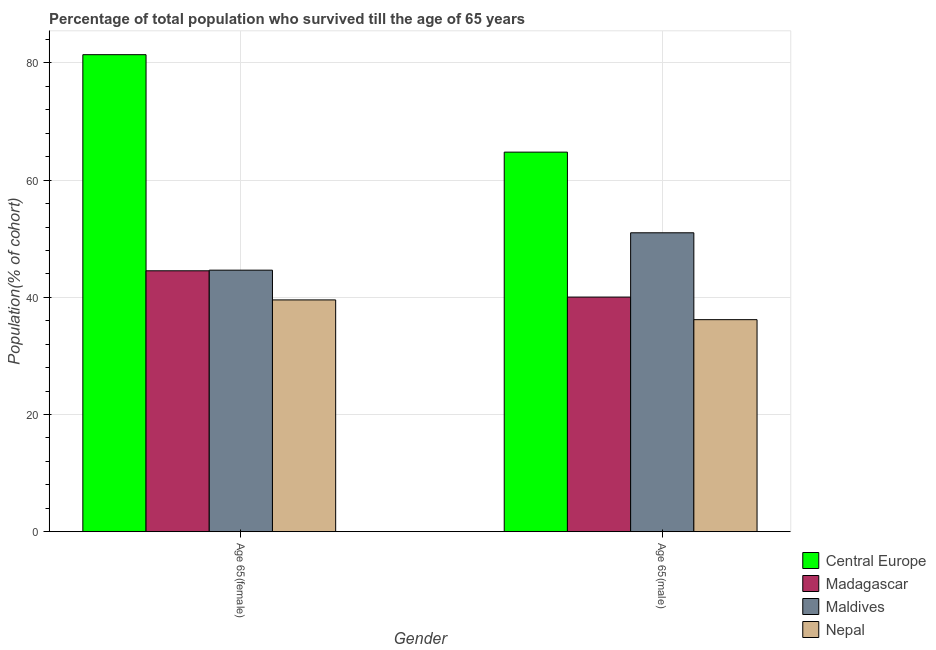How many bars are there on the 1st tick from the left?
Give a very brief answer. 4. What is the label of the 2nd group of bars from the left?
Keep it short and to the point. Age 65(male). What is the percentage of male population who survived till age of 65 in Madagascar?
Provide a succinct answer. 40.04. Across all countries, what is the maximum percentage of female population who survived till age of 65?
Provide a succinct answer. 81.41. Across all countries, what is the minimum percentage of female population who survived till age of 65?
Provide a succinct answer. 39.56. In which country was the percentage of female population who survived till age of 65 maximum?
Offer a terse response. Central Europe. In which country was the percentage of male population who survived till age of 65 minimum?
Offer a very short reply. Nepal. What is the total percentage of male population who survived till age of 65 in the graph?
Provide a succinct answer. 192.02. What is the difference between the percentage of female population who survived till age of 65 in Central Europe and that in Maldives?
Keep it short and to the point. 36.78. What is the difference between the percentage of female population who survived till age of 65 in Maldives and the percentage of male population who survived till age of 65 in Madagascar?
Provide a succinct answer. 4.59. What is the average percentage of female population who survived till age of 65 per country?
Your answer should be very brief. 52.53. What is the difference between the percentage of male population who survived till age of 65 and percentage of female population who survived till age of 65 in Madagascar?
Offer a terse response. -4.48. What is the ratio of the percentage of female population who survived till age of 65 in Nepal to that in Maldives?
Provide a succinct answer. 0.89. What does the 2nd bar from the left in Age 65(female) represents?
Keep it short and to the point. Madagascar. What does the 2nd bar from the right in Age 65(male) represents?
Offer a very short reply. Maldives. Are all the bars in the graph horizontal?
Your answer should be very brief. No. What is the difference between two consecutive major ticks on the Y-axis?
Your answer should be compact. 20. Does the graph contain any zero values?
Offer a terse response. No. Where does the legend appear in the graph?
Offer a very short reply. Bottom right. How many legend labels are there?
Offer a terse response. 4. What is the title of the graph?
Offer a very short reply. Percentage of total population who survived till the age of 65 years. What is the label or title of the Y-axis?
Offer a terse response. Population(% of cohort). What is the Population(% of cohort) of Central Europe in Age 65(female)?
Make the answer very short. 81.41. What is the Population(% of cohort) of Madagascar in Age 65(female)?
Provide a short and direct response. 44.53. What is the Population(% of cohort) in Maldives in Age 65(female)?
Provide a succinct answer. 44.63. What is the Population(% of cohort) in Nepal in Age 65(female)?
Offer a terse response. 39.56. What is the Population(% of cohort) in Central Europe in Age 65(male)?
Your answer should be compact. 64.78. What is the Population(% of cohort) of Madagascar in Age 65(male)?
Give a very brief answer. 40.04. What is the Population(% of cohort) in Maldives in Age 65(male)?
Ensure brevity in your answer.  51.01. What is the Population(% of cohort) of Nepal in Age 65(male)?
Provide a short and direct response. 36.19. Across all Gender, what is the maximum Population(% of cohort) of Central Europe?
Provide a succinct answer. 81.41. Across all Gender, what is the maximum Population(% of cohort) in Madagascar?
Your answer should be very brief. 44.53. Across all Gender, what is the maximum Population(% of cohort) of Maldives?
Your response must be concise. 51.01. Across all Gender, what is the maximum Population(% of cohort) in Nepal?
Your response must be concise. 39.56. Across all Gender, what is the minimum Population(% of cohort) in Central Europe?
Give a very brief answer. 64.78. Across all Gender, what is the minimum Population(% of cohort) of Madagascar?
Provide a succinct answer. 40.04. Across all Gender, what is the minimum Population(% of cohort) of Maldives?
Give a very brief answer. 44.63. Across all Gender, what is the minimum Population(% of cohort) in Nepal?
Provide a succinct answer. 36.19. What is the total Population(% of cohort) of Central Europe in the graph?
Provide a short and direct response. 146.19. What is the total Population(% of cohort) in Madagascar in the graph?
Your response must be concise. 84.57. What is the total Population(% of cohort) of Maldives in the graph?
Your answer should be compact. 95.65. What is the total Population(% of cohort) in Nepal in the graph?
Ensure brevity in your answer.  75.74. What is the difference between the Population(% of cohort) in Central Europe in Age 65(female) and that in Age 65(male)?
Make the answer very short. 16.63. What is the difference between the Population(% of cohort) in Madagascar in Age 65(female) and that in Age 65(male)?
Provide a succinct answer. 4.48. What is the difference between the Population(% of cohort) of Maldives in Age 65(female) and that in Age 65(male)?
Give a very brief answer. -6.38. What is the difference between the Population(% of cohort) in Nepal in Age 65(female) and that in Age 65(male)?
Your response must be concise. 3.37. What is the difference between the Population(% of cohort) in Central Europe in Age 65(female) and the Population(% of cohort) in Madagascar in Age 65(male)?
Offer a very short reply. 41.37. What is the difference between the Population(% of cohort) in Central Europe in Age 65(female) and the Population(% of cohort) in Maldives in Age 65(male)?
Give a very brief answer. 30.4. What is the difference between the Population(% of cohort) in Central Europe in Age 65(female) and the Population(% of cohort) in Nepal in Age 65(male)?
Your answer should be compact. 45.22. What is the difference between the Population(% of cohort) of Madagascar in Age 65(female) and the Population(% of cohort) of Maldives in Age 65(male)?
Offer a very short reply. -6.48. What is the difference between the Population(% of cohort) of Madagascar in Age 65(female) and the Population(% of cohort) of Nepal in Age 65(male)?
Keep it short and to the point. 8.34. What is the difference between the Population(% of cohort) in Maldives in Age 65(female) and the Population(% of cohort) in Nepal in Age 65(male)?
Ensure brevity in your answer.  8.45. What is the average Population(% of cohort) in Central Europe per Gender?
Provide a succinct answer. 73.09. What is the average Population(% of cohort) of Madagascar per Gender?
Provide a short and direct response. 42.29. What is the average Population(% of cohort) in Maldives per Gender?
Make the answer very short. 47.82. What is the average Population(% of cohort) of Nepal per Gender?
Your answer should be very brief. 37.87. What is the difference between the Population(% of cohort) in Central Europe and Population(% of cohort) in Madagascar in Age 65(female)?
Ensure brevity in your answer.  36.88. What is the difference between the Population(% of cohort) of Central Europe and Population(% of cohort) of Maldives in Age 65(female)?
Keep it short and to the point. 36.78. What is the difference between the Population(% of cohort) of Central Europe and Population(% of cohort) of Nepal in Age 65(female)?
Your answer should be compact. 41.85. What is the difference between the Population(% of cohort) in Madagascar and Population(% of cohort) in Maldives in Age 65(female)?
Ensure brevity in your answer.  -0.11. What is the difference between the Population(% of cohort) of Madagascar and Population(% of cohort) of Nepal in Age 65(female)?
Your answer should be very brief. 4.97. What is the difference between the Population(% of cohort) of Maldives and Population(% of cohort) of Nepal in Age 65(female)?
Your response must be concise. 5.08. What is the difference between the Population(% of cohort) of Central Europe and Population(% of cohort) of Madagascar in Age 65(male)?
Your answer should be very brief. 24.73. What is the difference between the Population(% of cohort) of Central Europe and Population(% of cohort) of Maldives in Age 65(male)?
Give a very brief answer. 13.76. What is the difference between the Population(% of cohort) of Central Europe and Population(% of cohort) of Nepal in Age 65(male)?
Offer a very short reply. 28.59. What is the difference between the Population(% of cohort) in Madagascar and Population(% of cohort) in Maldives in Age 65(male)?
Your answer should be compact. -10.97. What is the difference between the Population(% of cohort) in Madagascar and Population(% of cohort) in Nepal in Age 65(male)?
Your answer should be compact. 3.86. What is the difference between the Population(% of cohort) in Maldives and Population(% of cohort) in Nepal in Age 65(male)?
Your answer should be very brief. 14.83. What is the ratio of the Population(% of cohort) of Central Europe in Age 65(female) to that in Age 65(male)?
Provide a succinct answer. 1.26. What is the ratio of the Population(% of cohort) in Madagascar in Age 65(female) to that in Age 65(male)?
Make the answer very short. 1.11. What is the ratio of the Population(% of cohort) in Maldives in Age 65(female) to that in Age 65(male)?
Keep it short and to the point. 0.88. What is the ratio of the Population(% of cohort) of Nepal in Age 65(female) to that in Age 65(male)?
Your response must be concise. 1.09. What is the difference between the highest and the second highest Population(% of cohort) of Central Europe?
Offer a terse response. 16.63. What is the difference between the highest and the second highest Population(% of cohort) of Madagascar?
Your response must be concise. 4.48. What is the difference between the highest and the second highest Population(% of cohort) of Maldives?
Keep it short and to the point. 6.38. What is the difference between the highest and the second highest Population(% of cohort) of Nepal?
Your answer should be compact. 3.37. What is the difference between the highest and the lowest Population(% of cohort) in Central Europe?
Your response must be concise. 16.63. What is the difference between the highest and the lowest Population(% of cohort) in Madagascar?
Offer a terse response. 4.48. What is the difference between the highest and the lowest Population(% of cohort) in Maldives?
Make the answer very short. 6.38. What is the difference between the highest and the lowest Population(% of cohort) in Nepal?
Your answer should be compact. 3.37. 